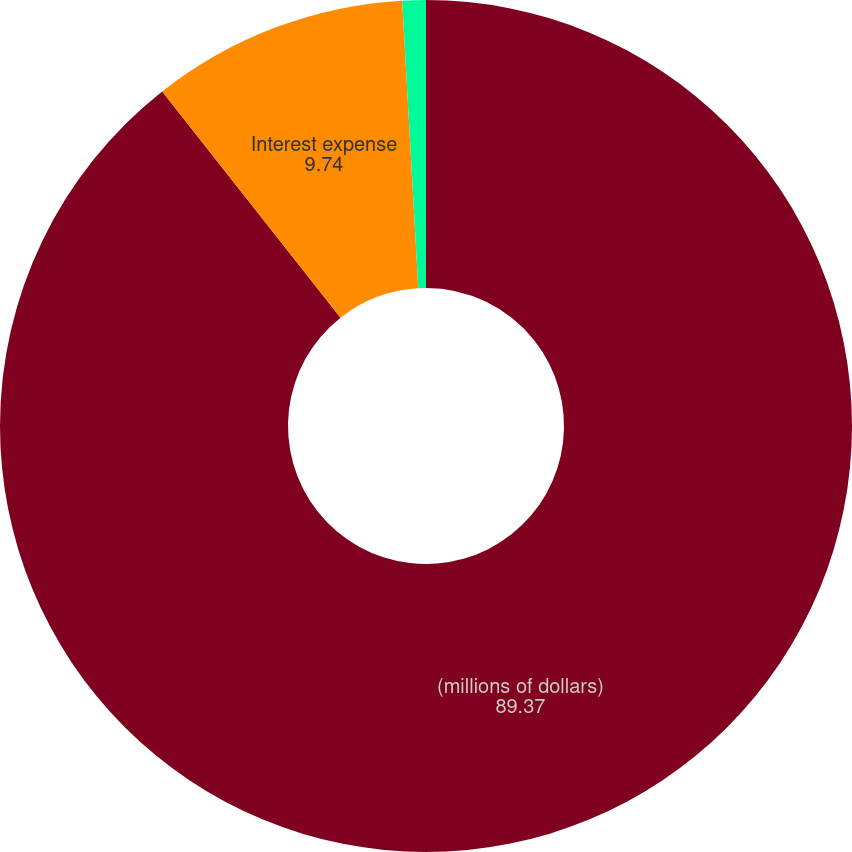Convert chart to OTSL. <chart><loc_0><loc_0><loc_500><loc_500><pie_chart><fcel>(millions of dollars)<fcel>Interest expense<fcel>Non-cash portion<nl><fcel>89.37%<fcel>9.74%<fcel>0.89%<nl></chart> 